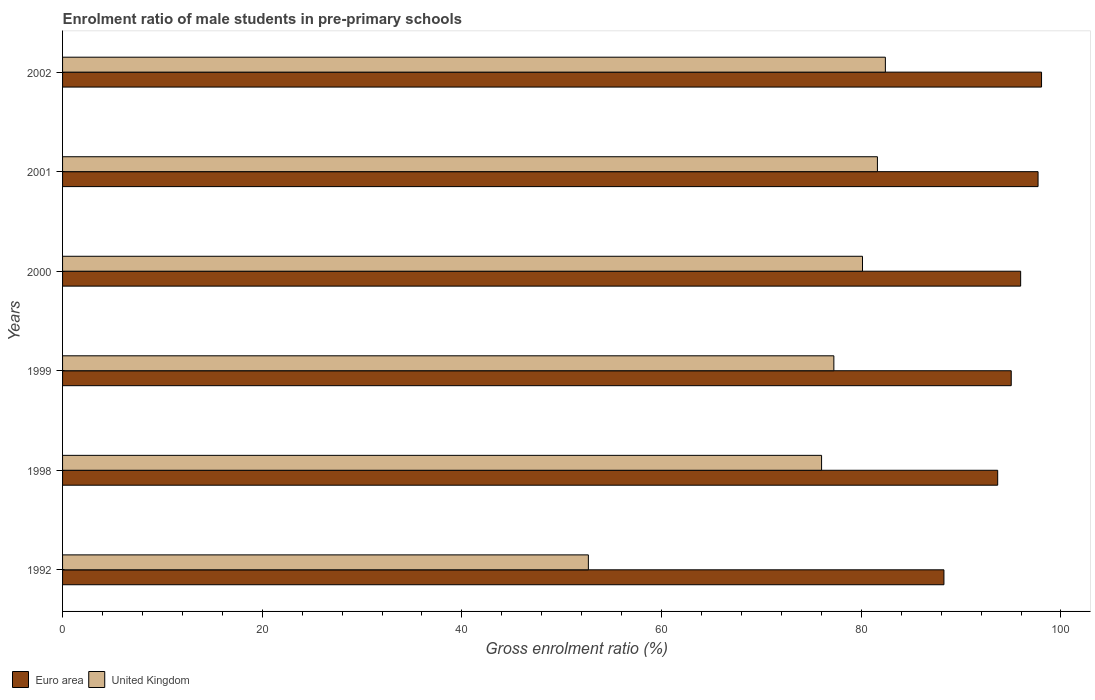How many different coloured bars are there?
Offer a very short reply. 2. Are the number of bars on each tick of the Y-axis equal?
Your response must be concise. Yes. How many bars are there on the 6th tick from the top?
Offer a very short reply. 2. What is the label of the 6th group of bars from the top?
Provide a short and direct response. 1992. What is the enrolment ratio of male students in pre-primary schools in Euro area in 1999?
Your answer should be compact. 95.02. Across all years, what is the maximum enrolment ratio of male students in pre-primary schools in United Kingdom?
Give a very brief answer. 82.41. Across all years, what is the minimum enrolment ratio of male students in pre-primary schools in Euro area?
Give a very brief answer. 88.28. In which year was the enrolment ratio of male students in pre-primary schools in Euro area minimum?
Provide a short and direct response. 1992. What is the total enrolment ratio of male students in pre-primary schools in Euro area in the graph?
Offer a terse response. 568.69. What is the difference between the enrolment ratio of male students in pre-primary schools in United Kingdom in 2001 and that in 2002?
Offer a terse response. -0.8. What is the difference between the enrolment ratio of male students in pre-primary schools in United Kingdom in 1998 and the enrolment ratio of male students in pre-primary schools in Euro area in 1999?
Provide a short and direct response. -19. What is the average enrolment ratio of male students in pre-primary schools in United Kingdom per year?
Keep it short and to the point. 75.02. In the year 2000, what is the difference between the enrolment ratio of male students in pre-primary schools in United Kingdom and enrolment ratio of male students in pre-primary schools in Euro area?
Ensure brevity in your answer.  -15.84. In how many years, is the enrolment ratio of male students in pre-primary schools in United Kingdom greater than 56 %?
Your answer should be very brief. 5. What is the ratio of the enrolment ratio of male students in pre-primary schools in United Kingdom in 2001 to that in 2002?
Offer a very short reply. 0.99. Is the difference between the enrolment ratio of male students in pre-primary schools in United Kingdom in 1992 and 2002 greater than the difference between the enrolment ratio of male students in pre-primary schools in Euro area in 1992 and 2002?
Your answer should be very brief. No. What is the difference between the highest and the second highest enrolment ratio of male students in pre-primary schools in United Kingdom?
Give a very brief answer. 0.8. What is the difference between the highest and the lowest enrolment ratio of male students in pre-primary schools in Euro area?
Provide a succinct answer. 9.78. What does the 2nd bar from the top in 2002 represents?
Your answer should be very brief. Euro area. What does the 2nd bar from the bottom in 2001 represents?
Your response must be concise. United Kingdom. How many bars are there?
Provide a succinct answer. 12. How many years are there in the graph?
Your answer should be very brief. 6. Are the values on the major ticks of X-axis written in scientific E-notation?
Offer a very short reply. No. Does the graph contain grids?
Your answer should be compact. No. How many legend labels are there?
Your response must be concise. 2. What is the title of the graph?
Your response must be concise. Enrolment ratio of male students in pre-primary schools. Does "Grenada" appear as one of the legend labels in the graph?
Your answer should be very brief. No. What is the Gross enrolment ratio (%) of Euro area in 1992?
Keep it short and to the point. 88.28. What is the Gross enrolment ratio (%) of United Kingdom in 1992?
Ensure brevity in your answer.  52.66. What is the Gross enrolment ratio (%) of Euro area in 1998?
Offer a terse response. 93.66. What is the Gross enrolment ratio (%) in United Kingdom in 1998?
Provide a succinct answer. 76.02. What is the Gross enrolment ratio (%) in Euro area in 1999?
Ensure brevity in your answer.  95.02. What is the Gross enrolment ratio (%) in United Kingdom in 1999?
Provide a short and direct response. 77.25. What is the Gross enrolment ratio (%) in Euro area in 2000?
Your answer should be very brief. 95.96. What is the Gross enrolment ratio (%) of United Kingdom in 2000?
Offer a terse response. 80.12. What is the Gross enrolment ratio (%) of Euro area in 2001?
Make the answer very short. 97.71. What is the Gross enrolment ratio (%) of United Kingdom in 2001?
Offer a terse response. 81.62. What is the Gross enrolment ratio (%) in Euro area in 2002?
Make the answer very short. 98.06. What is the Gross enrolment ratio (%) of United Kingdom in 2002?
Offer a very short reply. 82.41. Across all years, what is the maximum Gross enrolment ratio (%) in Euro area?
Your answer should be very brief. 98.06. Across all years, what is the maximum Gross enrolment ratio (%) of United Kingdom?
Your answer should be compact. 82.41. Across all years, what is the minimum Gross enrolment ratio (%) in Euro area?
Offer a terse response. 88.28. Across all years, what is the minimum Gross enrolment ratio (%) of United Kingdom?
Offer a very short reply. 52.66. What is the total Gross enrolment ratio (%) of Euro area in the graph?
Offer a terse response. 568.69. What is the total Gross enrolment ratio (%) of United Kingdom in the graph?
Make the answer very short. 450.09. What is the difference between the Gross enrolment ratio (%) of Euro area in 1992 and that in 1998?
Your response must be concise. -5.38. What is the difference between the Gross enrolment ratio (%) of United Kingdom in 1992 and that in 1998?
Your answer should be very brief. -23.36. What is the difference between the Gross enrolment ratio (%) in Euro area in 1992 and that in 1999?
Give a very brief answer. -6.74. What is the difference between the Gross enrolment ratio (%) in United Kingdom in 1992 and that in 1999?
Ensure brevity in your answer.  -24.59. What is the difference between the Gross enrolment ratio (%) of Euro area in 1992 and that in 2000?
Offer a terse response. -7.68. What is the difference between the Gross enrolment ratio (%) in United Kingdom in 1992 and that in 2000?
Give a very brief answer. -27.46. What is the difference between the Gross enrolment ratio (%) in Euro area in 1992 and that in 2001?
Ensure brevity in your answer.  -9.43. What is the difference between the Gross enrolment ratio (%) of United Kingdom in 1992 and that in 2001?
Your answer should be compact. -28.95. What is the difference between the Gross enrolment ratio (%) of Euro area in 1992 and that in 2002?
Your answer should be compact. -9.78. What is the difference between the Gross enrolment ratio (%) of United Kingdom in 1992 and that in 2002?
Make the answer very short. -29.75. What is the difference between the Gross enrolment ratio (%) in Euro area in 1998 and that in 1999?
Your response must be concise. -1.36. What is the difference between the Gross enrolment ratio (%) of United Kingdom in 1998 and that in 1999?
Your answer should be compact. -1.23. What is the difference between the Gross enrolment ratio (%) of Euro area in 1998 and that in 2000?
Make the answer very short. -2.3. What is the difference between the Gross enrolment ratio (%) of United Kingdom in 1998 and that in 2000?
Offer a very short reply. -4.1. What is the difference between the Gross enrolment ratio (%) in Euro area in 1998 and that in 2001?
Your answer should be compact. -4.04. What is the difference between the Gross enrolment ratio (%) in United Kingdom in 1998 and that in 2001?
Your answer should be compact. -5.59. What is the difference between the Gross enrolment ratio (%) of Euro area in 1998 and that in 2002?
Provide a succinct answer. -4.39. What is the difference between the Gross enrolment ratio (%) in United Kingdom in 1998 and that in 2002?
Provide a succinct answer. -6.39. What is the difference between the Gross enrolment ratio (%) of Euro area in 1999 and that in 2000?
Your response must be concise. -0.94. What is the difference between the Gross enrolment ratio (%) in United Kingdom in 1999 and that in 2000?
Your answer should be compact. -2.87. What is the difference between the Gross enrolment ratio (%) of Euro area in 1999 and that in 2001?
Your answer should be very brief. -2.69. What is the difference between the Gross enrolment ratio (%) in United Kingdom in 1999 and that in 2001?
Offer a terse response. -4.36. What is the difference between the Gross enrolment ratio (%) of Euro area in 1999 and that in 2002?
Provide a succinct answer. -3.04. What is the difference between the Gross enrolment ratio (%) of United Kingdom in 1999 and that in 2002?
Give a very brief answer. -5.16. What is the difference between the Gross enrolment ratio (%) of Euro area in 2000 and that in 2001?
Provide a short and direct response. -1.74. What is the difference between the Gross enrolment ratio (%) of United Kingdom in 2000 and that in 2001?
Offer a very short reply. -1.49. What is the difference between the Gross enrolment ratio (%) in Euro area in 2000 and that in 2002?
Provide a succinct answer. -2.09. What is the difference between the Gross enrolment ratio (%) of United Kingdom in 2000 and that in 2002?
Your response must be concise. -2.29. What is the difference between the Gross enrolment ratio (%) of Euro area in 2001 and that in 2002?
Offer a very short reply. -0.35. What is the difference between the Gross enrolment ratio (%) of United Kingdom in 2001 and that in 2002?
Keep it short and to the point. -0.8. What is the difference between the Gross enrolment ratio (%) of Euro area in 1992 and the Gross enrolment ratio (%) of United Kingdom in 1998?
Make the answer very short. 12.26. What is the difference between the Gross enrolment ratio (%) in Euro area in 1992 and the Gross enrolment ratio (%) in United Kingdom in 1999?
Offer a terse response. 11.03. What is the difference between the Gross enrolment ratio (%) in Euro area in 1992 and the Gross enrolment ratio (%) in United Kingdom in 2000?
Your answer should be very brief. 8.16. What is the difference between the Gross enrolment ratio (%) in Euro area in 1992 and the Gross enrolment ratio (%) in United Kingdom in 2001?
Make the answer very short. 6.66. What is the difference between the Gross enrolment ratio (%) of Euro area in 1992 and the Gross enrolment ratio (%) of United Kingdom in 2002?
Offer a very short reply. 5.87. What is the difference between the Gross enrolment ratio (%) in Euro area in 1998 and the Gross enrolment ratio (%) in United Kingdom in 1999?
Ensure brevity in your answer.  16.41. What is the difference between the Gross enrolment ratio (%) of Euro area in 1998 and the Gross enrolment ratio (%) of United Kingdom in 2000?
Keep it short and to the point. 13.54. What is the difference between the Gross enrolment ratio (%) in Euro area in 1998 and the Gross enrolment ratio (%) in United Kingdom in 2001?
Your answer should be compact. 12.05. What is the difference between the Gross enrolment ratio (%) in Euro area in 1998 and the Gross enrolment ratio (%) in United Kingdom in 2002?
Make the answer very short. 11.25. What is the difference between the Gross enrolment ratio (%) in Euro area in 1999 and the Gross enrolment ratio (%) in United Kingdom in 2000?
Provide a short and direct response. 14.9. What is the difference between the Gross enrolment ratio (%) in Euro area in 1999 and the Gross enrolment ratio (%) in United Kingdom in 2001?
Give a very brief answer. 13.4. What is the difference between the Gross enrolment ratio (%) of Euro area in 1999 and the Gross enrolment ratio (%) of United Kingdom in 2002?
Ensure brevity in your answer.  12.61. What is the difference between the Gross enrolment ratio (%) in Euro area in 2000 and the Gross enrolment ratio (%) in United Kingdom in 2001?
Your response must be concise. 14.35. What is the difference between the Gross enrolment ratio (%) of Euro area in 2000 and the Gross enrolment ratio (%) of United Kingdom in 2002?
Offer a very short reply. 13.55. What is the difference between the Gross enrolment ratio (%) of Euro area in 2001 and the Gross enrolment ratio (%) of United Kingdom in 2002?
Keep it short and to the point. 15.29. What is the average Gross enrolment ratio (%) in Euro area per year?
Your answer should be compact. 94.78. What is the average Gross enrolment ratio (%) in United Kingdom per year?
Make the answer very short. 75.02. In the year 1992, what is the difference between the Gross enrolment ratio (%) of Euro area and Gross enrolment ratio (%) of United Kingdom?
Offer a very short reply. 35.61. In the year 1998, what is the difference between the Gross enrolment ratio (%) of Euro area and Gross enrolment ratio (%) of United Kingdom?
Make the answer very short. 17.64. In the year 1999, what is the difference between the Gross enrolment ratio (%) of Euro area and Gross enrolment ratio (%) of United Kingdom?
Your response must be concise. 17.77. In the year 2000, what is the difference between the Gross enrolment ratio (%) in Euro area and Gross enrolment ratio (%) in United Kingdom?
Your response must be concise. 15.84. In the year 2001, what is the difference between the Gross enrolment ratio (%) of Euro area and Gross enrolment ratio (%) of United Kingdom?
Ensure brevity in your answer.  16.09. In the year 2002, what is the difference between the Gross enrolment ratio (%) of Euro area and Gross enrolment ratio (%) of United Kingdom?
Make the answer very short. 15.64. What is the ratio of the Gross enrolment ratio (%) in Euro area in 1992 to that in 1998?
Provide a short and direct response. 0.94. What is the ratio of the Gross enrolment ratio (%) in United Kingdom in 1992 to that in 1998?
Your answer should be compact. 0.69. What is the ratio of the Gross enrolment ratio (%) of Euro area in 1992 to that in 1999?
Keep it short and to the point. 0.93. What is the ratio of the Gross enrolment ratio (%) of United Kingdom in 1992 to that in 1999?
Offer a terse response. 0.68. What is the ratio of the Gross enrolment ratio (%) in Euro area in 1992 to that in 2000?
Your response must be concise. 0.92. What is the ratio of the Gross enrolment ratio (%) of United Kingdom in 1992 to that in 2000?
Keep it short and to the point. 0.66. What is the ratio of the Gross enrolment ratio (%) of Euro area in 1992 to that in 2001?
Your answer should be very brief. 0.9. What is the ratio of the Gross enrolment ratio (%) of United Kingdom in 1992 to that in 2001?
Provide a short and direct response. 0.65. What is the ratio of the Gross enrolment ratio (%) of Euro area in 1992 to that in 2002?
Keep it short and to the point. 0.9. What is the ratio of the Gross enrolment ratio (%) in United Kingdom in 1992 to that in 2002?
Keep it short and to the point. 0.64. What is the ratio of the Gross enrolment ratio (%) of Euro area in 1998 to that in 1999?
Provide a short and direct response. 0.99. What is the ratio of the Gross enrolment ratio (%) of United Kingdom in 1998 to that in 1999?
Make the answer very short. 0.98. What is the ratio of the Gross enrolment ratio (%) of United Kingdom in 1998 to that in 2000?
Make the answer very short. 0.95. What is the ratio of the Gross enrolment ratio (%) in Euro area in 1998 to that in 2001?
Your response must be concise. 0.96. What is the ratio of the Gross enrolment ratio (%) of United Kingdom in 1998 to that in 2001?
Your answer should be compact. 0.93. What is the ratio of the Gross enrolment ratio (%) of Euro area in 1998 to that in 2002?
Your response must be concise. 0.96. What is the ratio of the Gross enrolment ratio (%) of United Kingdom in 1998 to that in 2002?
Your answer should be compact. 0.92. What is the ratio of the Gross enrolment ratio (%) of Euro area in 1999 to that in 2000?
Ensure brevity in your answer.  0.99. What is the ratio of the Gross enrolment ratio (%) of United Kingdom in 1999 to that in 2000?
Give a very brief answer. 0.96. What is the ratio of the Gross enrolment ratio (%) of Euro area in 1999 to that in 2001?
Provide a short and direct response. 0.97. What is the ratio of the Gross enrolment ratio (%) in United Kingdom in 1999 to that in 2001?
Your answer should be compact. 0.95. What is the ratio of the Gross enrolment ratio (%) in Euro area in 1999 to that in 2002?
Ensure brevity in your answer.  0.97. What is the ratio of the Gross enrolment ratio (%) of United Kingdom in 1999 to that in 2002?
Provide a short and direct response. 0.94. What is the ratio of the Gross enrolment ratio (%) of Euro area in 2000 to that in 2001?
Keep it short and to the point. 0.98. What is the ratio of the Gross enrolment ratio (%) in United Kingdom in 2000 to that in 2001?
Offer a terse response. 0.98. What is the ratio of the Gross enrolment ratio (%) in Euro area in 2000 to that in 2002?
Provide a short and direct response. 0.98. What is the ratio of the Gross enrolment ratio (%) of United Kingdom in 2000 to that in 2002?
Your response must be concise. 0.97. What is the ratio of the Gross enrolment ratio (%) in United Kingdom in 2001 to that in 2002?
Keep it short and to the point. 0.99. What is the difference between the highest and the second highest Gross enrolment ratio (%) of Euro area?
Offer a terse response. 0.35. What is the difference between the highest and the second highest Gross enrolment ratio (%) in United Kingdom?
Ensure brevity in your answer.  0.8. What is the difference between the highest and the lowest Gross enrolment ratio (%) of Euro area?
Give a very brief answer. 9.78. What is the difference between the highest and the lowest Gross enrolment ratio (%) in United Kingdom?
Provide a succinct answer. 29.75. 